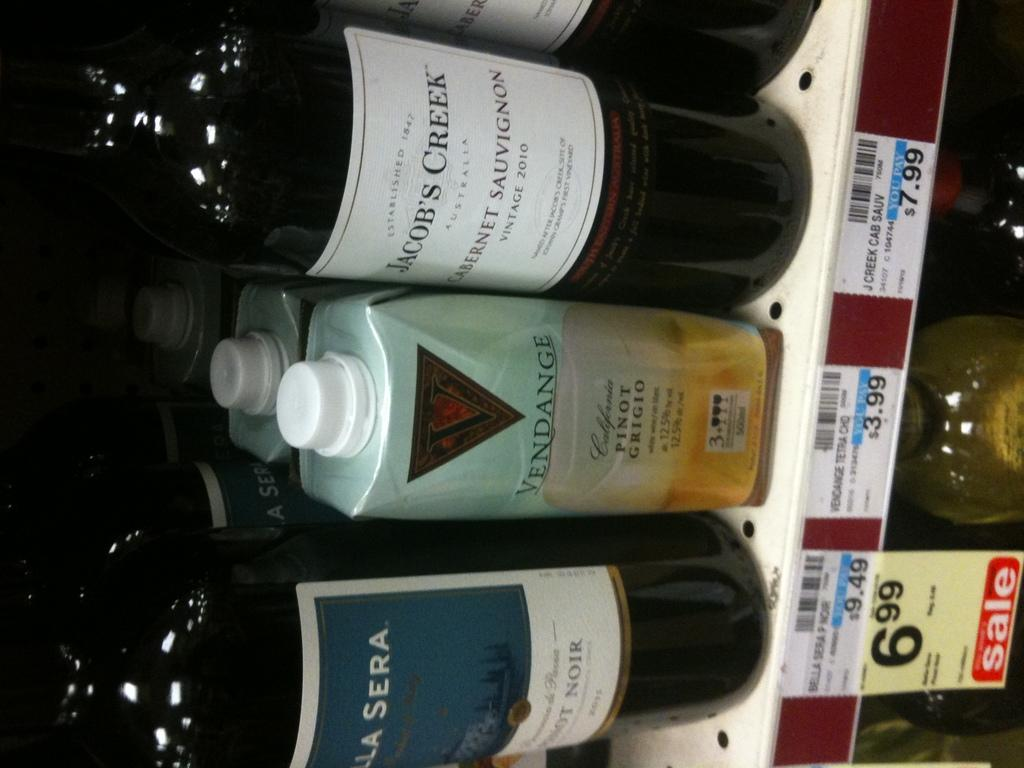<image>
Give a short and clear explanation of the subsequent image. Bottles of wine on a shelf with one bottle saying Jacob's Creek. 